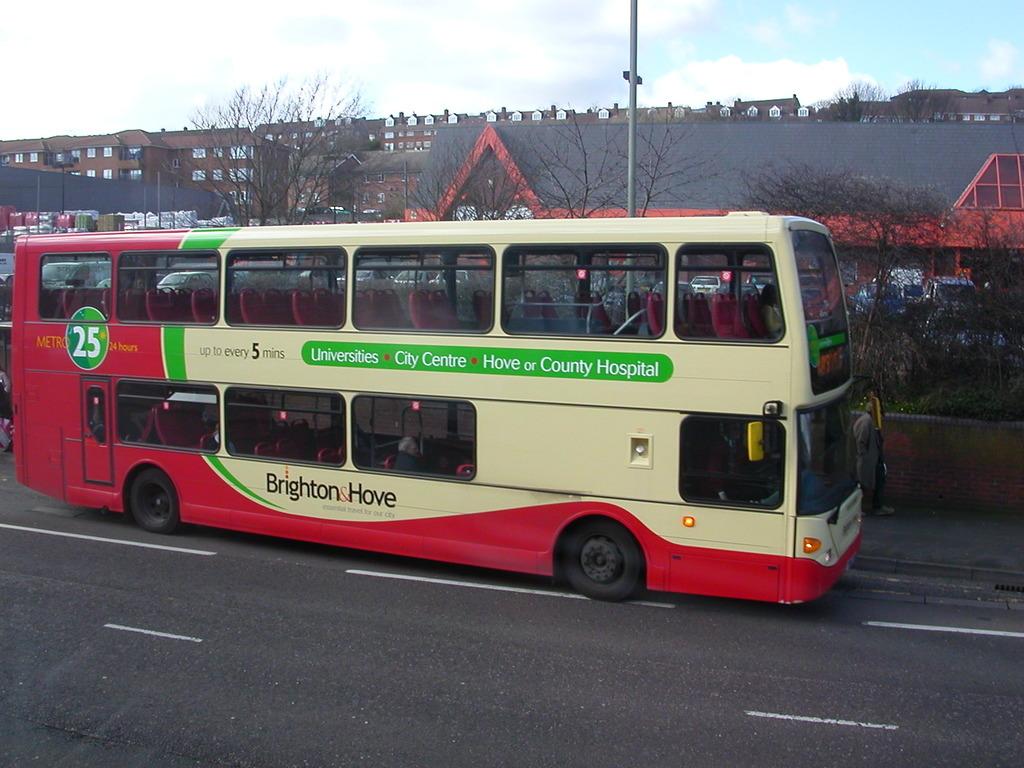Where does this bus go?
Your answer should be very brief. Universities, city centre, hove or county hospital. How many hours does this bus run?
Provide a succinct answer. 24. 